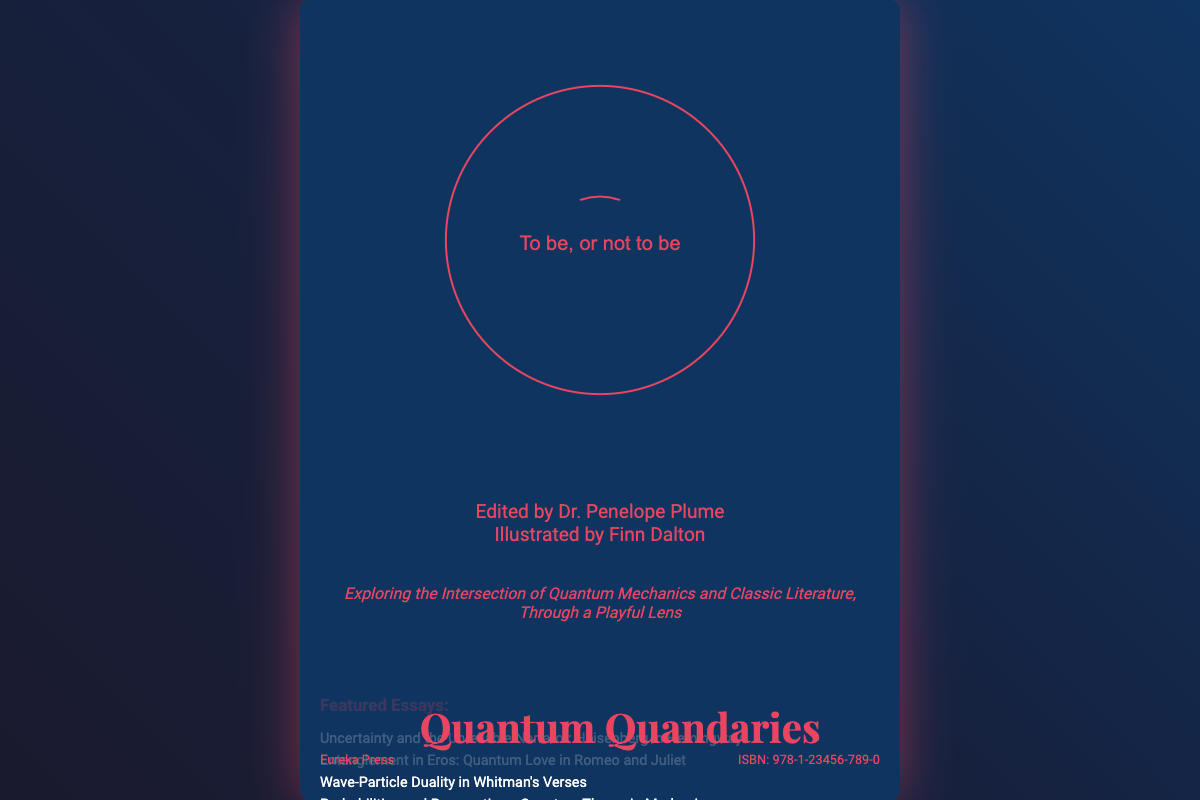What is the title of the book? The title is prominently displayed at the top of the cover, stating "Quantum Quandaries."
Answer: Quantum Quandaries Who edited the book? The editor's name is found beneath the title, listed as Dr. Penelope Plume.
Answer: Dr. Penelope Plume Which publisher released the book? The publisher's name is located at the bottom left of the cover, which is Eureka Press.
Answer: Eureka Press What is the ISBN of the book? The ISBN is clearly shown in the bottom right corner of the cover.
Answer: 978-1-23456-789-0 What visual elements are featured on the cover? The cover includes an illustration of Schrödinger's cat reading a Shakespearean sonnet among other imaginative designs.
Answer: Schrödinger's cat How many essays are featured in the book? The number of essays can be inferred from the list within the cover, totaling five.
Answer: Five What literary work is referenced in the subtitle? Words in the subtitle indicate a focus on classic literature, specifically mentioning Shakespearean themes.
Answer: Shakespeare What is the main theme of the book? The tagline summarizing the content highlights the connection between quantum mechanics and classic literature.
Answer: Quantum mechanics and classic literature Which essay explores themes of love? The featured essays list includes one that connects love with quantum concepts, titled "Entanglement in Eros: Quantum Love in Romeo and Juliet."
Answer: Entanglement in Eros: Quantum Love in Romeo and Juliet 